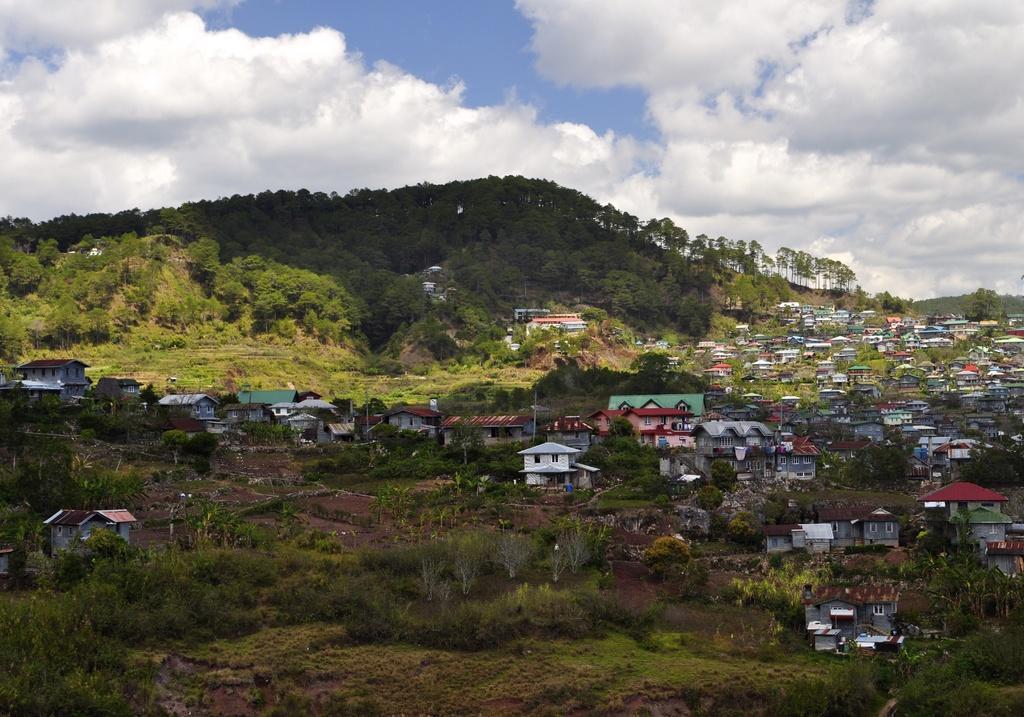Describe this image in one or two sentences. This picture is clicked outside. In the foreground we can see the green grass, plants and many number of houses. In the background we can see the sky which is full of clouds and we can see the trees and many other objects. 